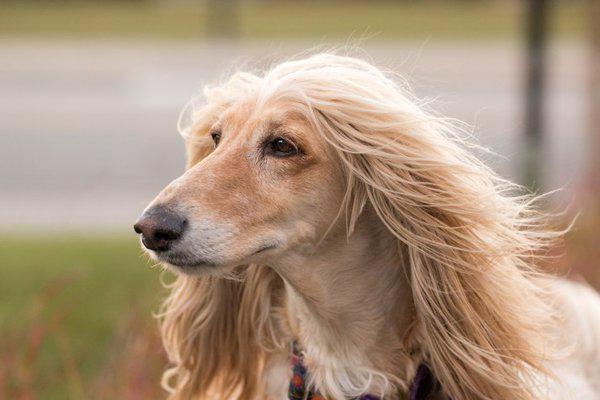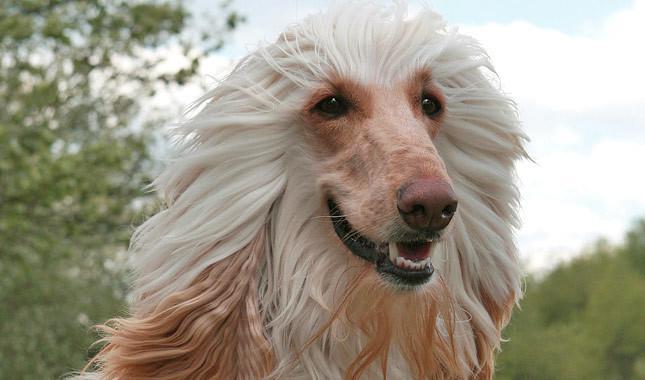The first image is the image on the left, the second image is the image on the right. Examine the images to the left and right. Is the description "There is at least one dog sitting in the image on the left" accurate? Answer yes or no. No. 